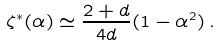Convert formula to latex. <formula><loc_0><loc_0><loc_500><loc_500>\zeta ^ { * } ( \alpha ) \simeq \frac { 2 + d } { 4 d } ( 1 - \alpha ^ { 2 } ) \, .</formula> 